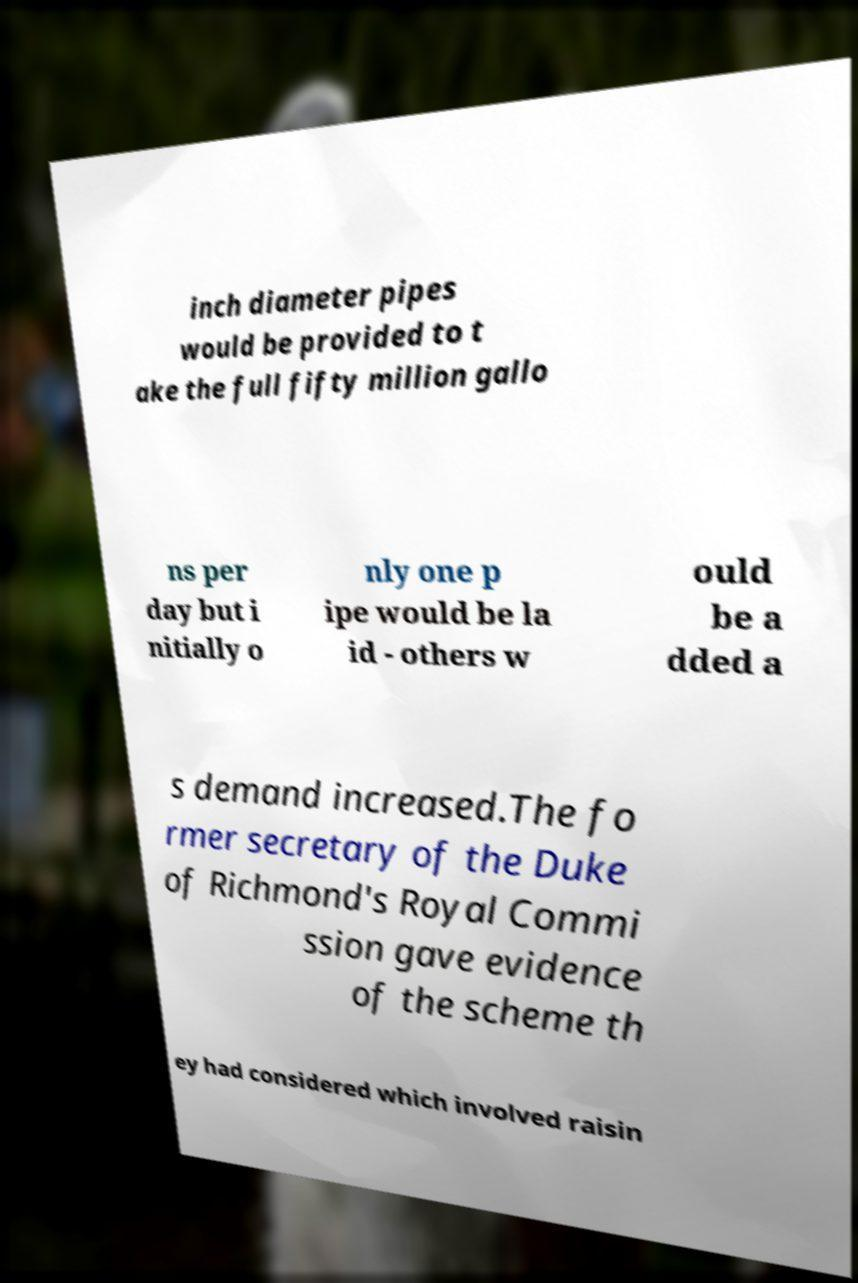Please identify and transcribe the text found in this image. inch diameter pipes would be provided to t ake the full fifty million gallo ns per day but i nitially o nly one p ipe would be la id - others w ould be a dded a s demand increased.The fo rmer secretary of the Duke of Richmond's Royal Commi ssion gave evidence of the scheme th ey had considered which involved raisin 